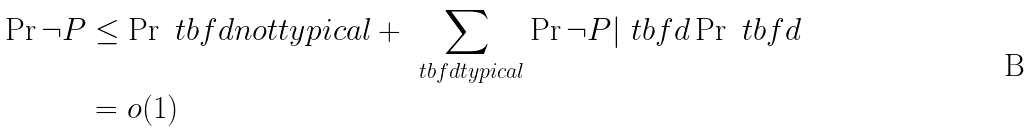Convert formula to latex. <formula><loc_0><loc_0><loc_500><loc_500>\Pr { \neg P } & \leq \Pr { \ t b f { d } n o t t y p i c a l } + \sum _ { \ t b f { d } t y p i c a l } \Pr { \neg P | \ t b f { d } } \Pr { \ t b f { d } } \\ & = o ( 1 )</formula> 